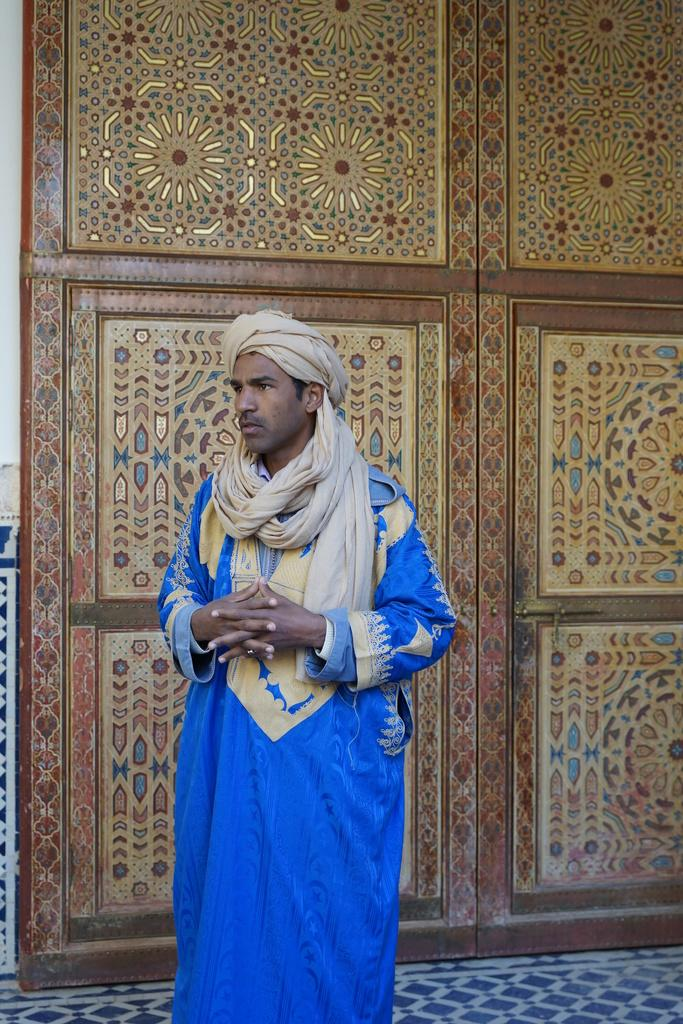What is the main subject of the image? There is a person standing in the image. What is the person wearing? The person is wearing a blue dress. What can be seen behind the person in the image? The background of the image appears to be a wall. How many cows are visible in the image? There are no cows visible in the image; it features a person standing in front of a wall. What type of blade is being used by the person in the image? There is no blade present in the image; the person is simply standing in front of a wall. 